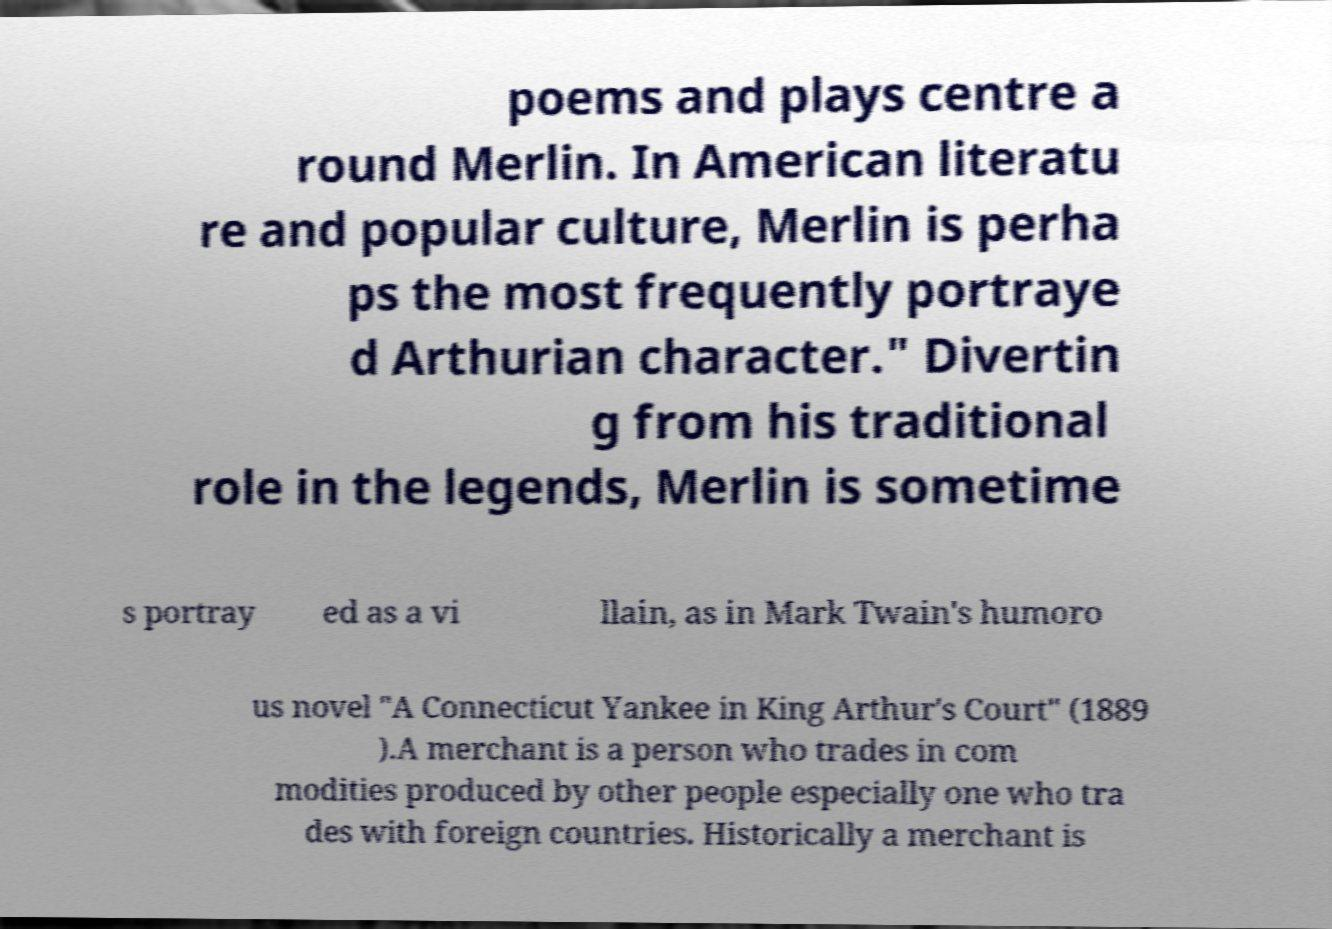Could you assist in decoding the text presented in this image and type it out clearly? poems and plays centre a round Merlin. In American literatu re and popular culture, Merlin is perha ps the most frequently portraye d Arthurian character." Divertin g from his traditional role in the legends, Merlin is sometime s portray ed as a vi llain, as in Mark Twain's humoro us novel "A Connecticut Yankee in King Arthur's Court" (1889 ).A merchant is a person who trades in com modities produced by other people especially one who tra des with foreign countries. Historically a merchant is 